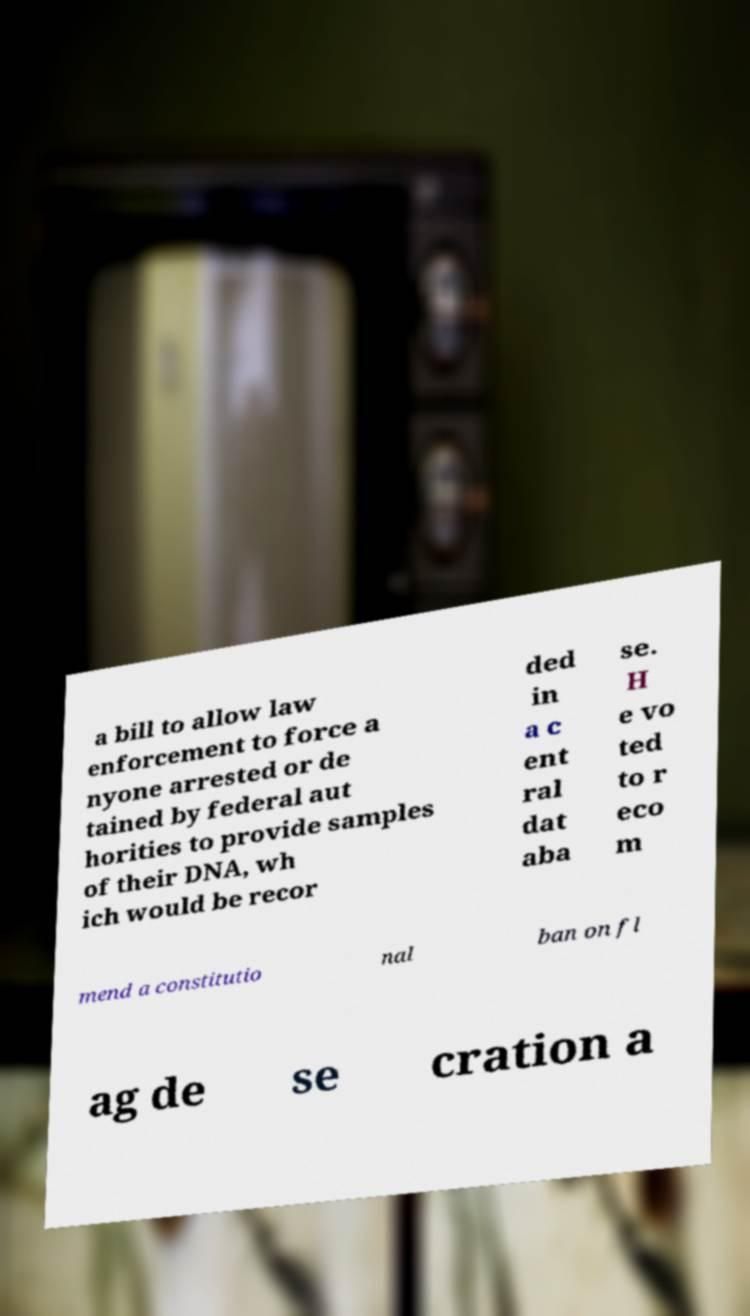Please read and relay the text visible in this image. What does it say? a bill to allow law enforcement to force a nyone arrested or de tained by federal aut horities to provide samples of their DNA, wh ich would be recor ded in a c ent ral dat aba se. H e vo ted to r eco m mend a constitutio nal ban on fl ag de se cration a 